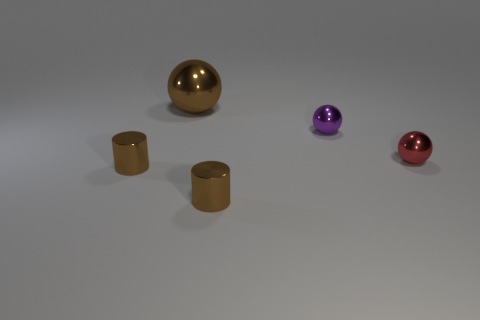Can you describe the textures of the objects? Yes, the spheres have a smooth, reflective texture with a metallic sheen, indicative of polished metal, while the cylinders appear to have a muted matte texture. Do the objects cast shadows? Each object casts a soft shadow on what appears to be a light gray surface, suggesting a source of light in the environment. 